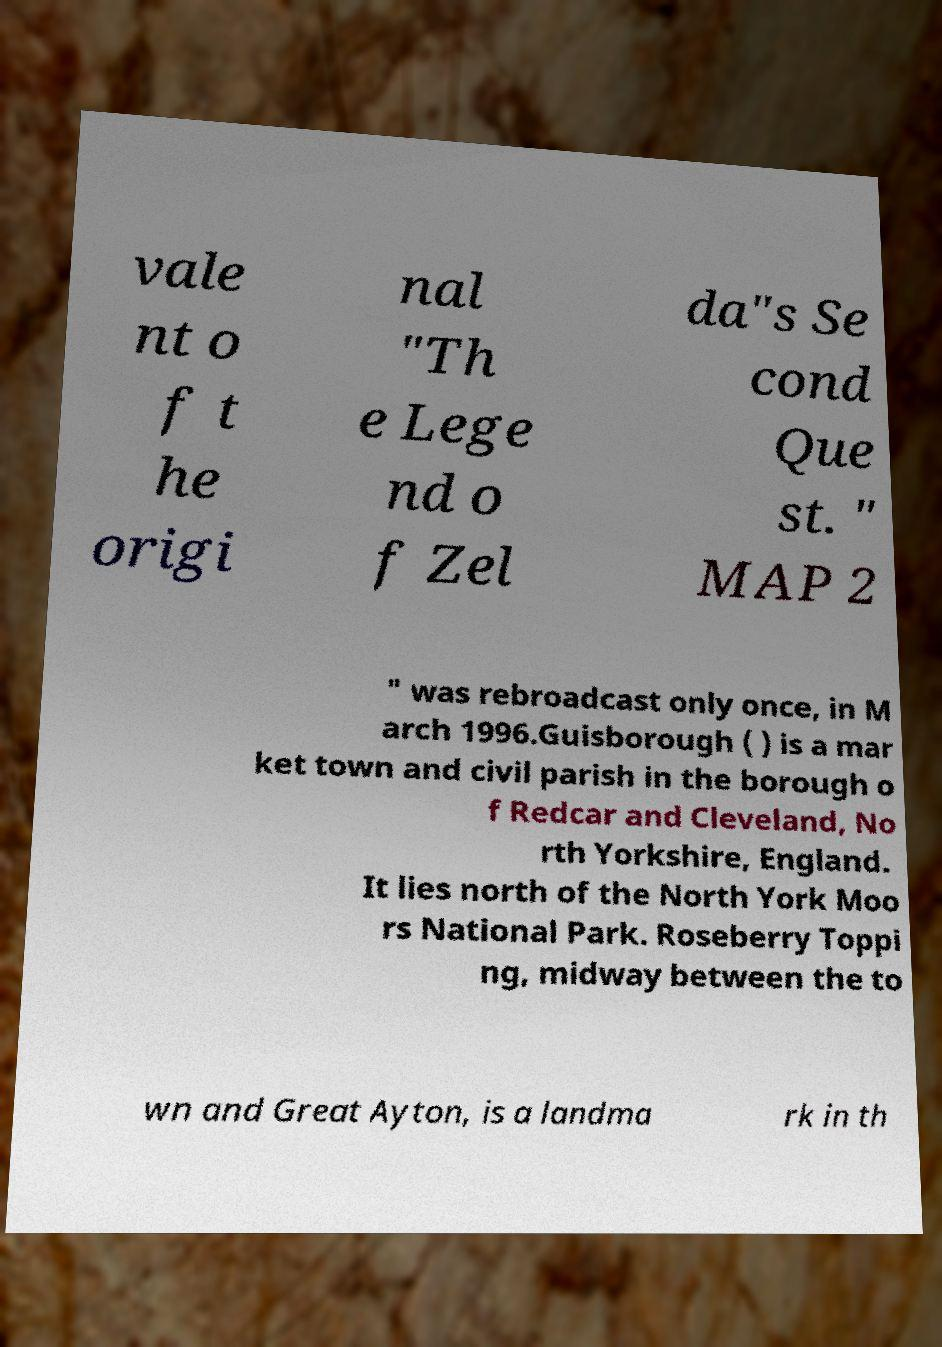For documentation purposes, I need the text within this image transcribed. Could you provide that? vale nt o f t he origi nal "Th e Lege nd o f Zel da"s Se cond Que st. " MAP 2 " was rebroadcast only once, in M arch 1996.Guisborough ( ) is a mar ket town and civil parish in the borough o f Redcar and Cleveland, No rth Yorkshire, England. It lies north of the North York Moo rs National Park. Roseberry Toppi ng, midway between the to wn and Great Ayton, is a landma rk in th 